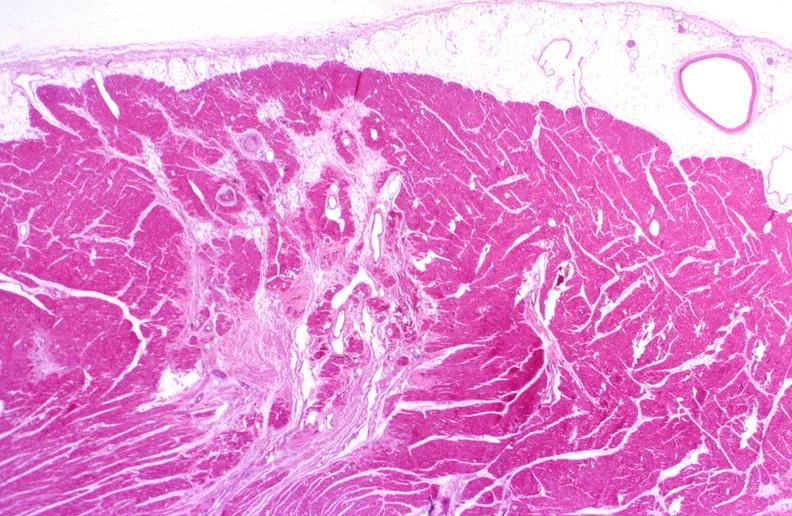does infant body show heart, polyarteritis nodosa?
Answer the question using a single word or phrase. No 